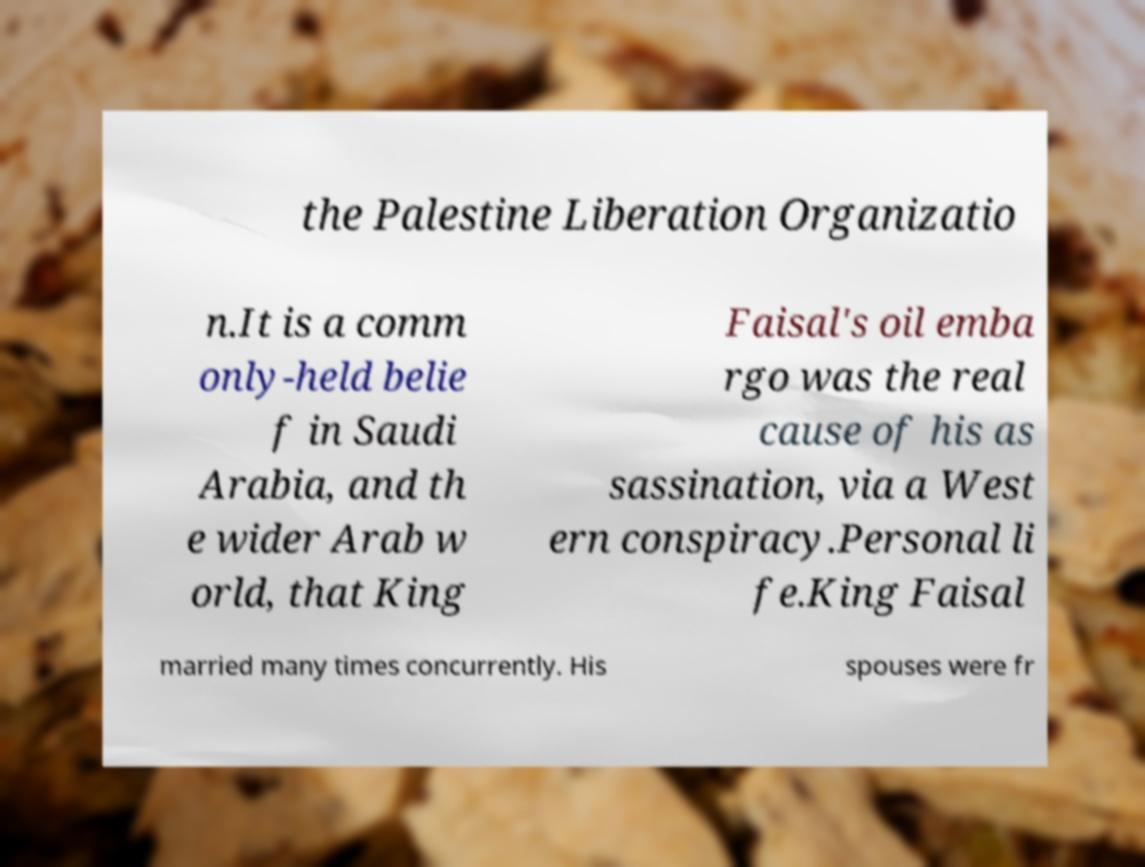Please read and relay the text visible in this image. What does it say? the Palestine Liberation Organizatio n.It is a comm only-held belie f in Saudi Arabia, and th e wider Arab w orld, that King Faisal's oil emba rgo was the real cause of his as sassination, via a West ern conspiracy.Personal li fe.King Faisal married many times concurrently. His spouses were fr 